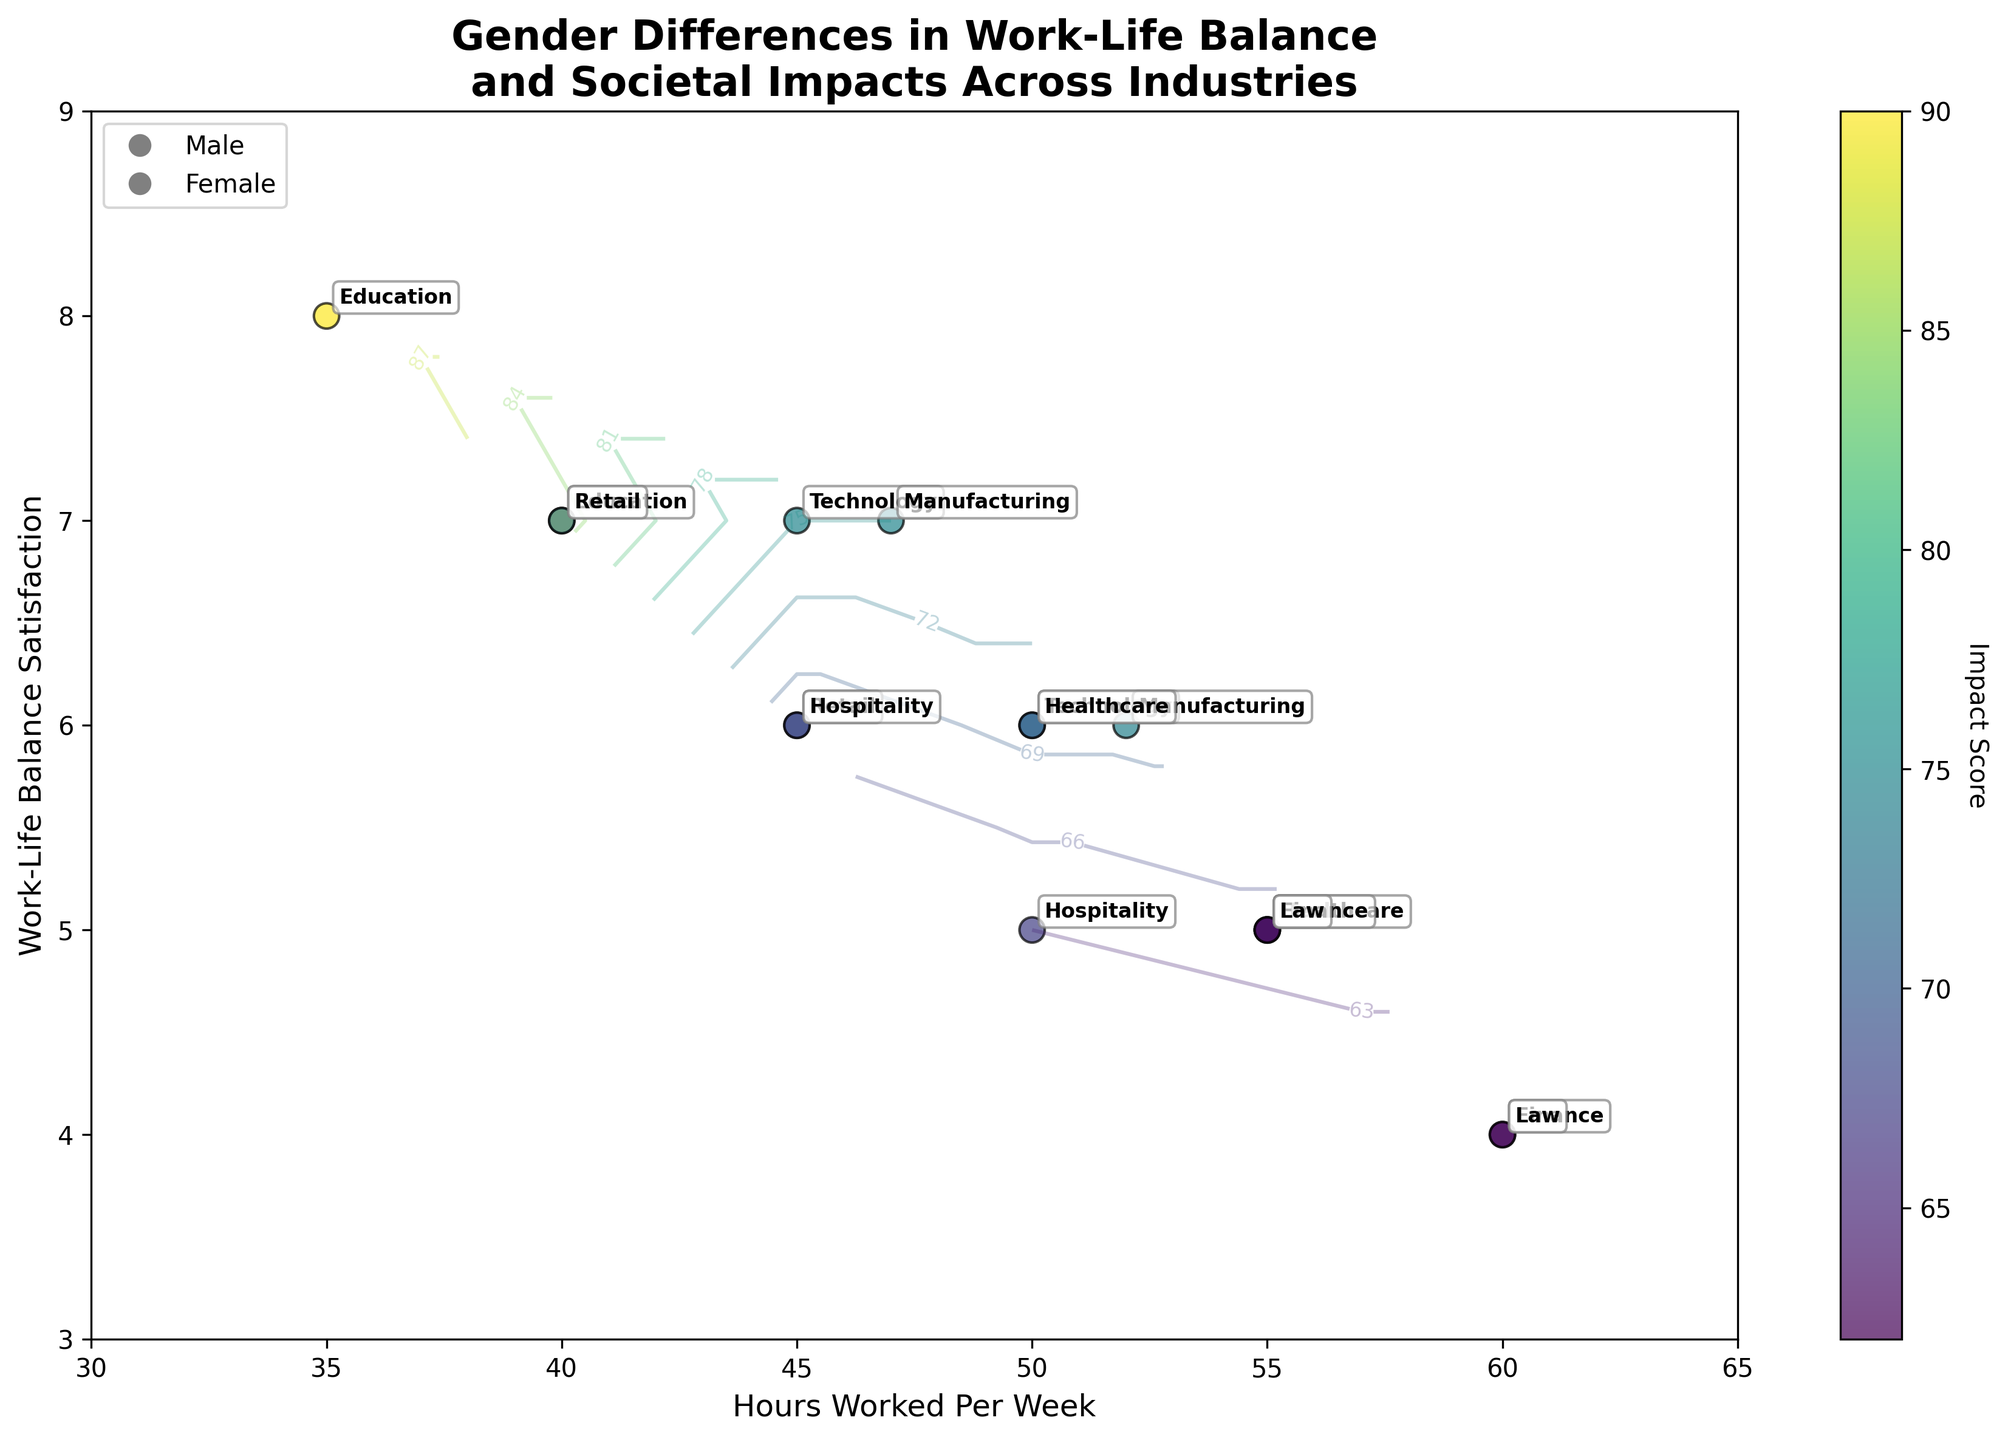What's the title of the figure? The title is at the top of the figure. It reads: "Gender Differences in Work-Life Balance and Societal Impacts Across Industries".
Answer: Gender Differences in Work-Life Balance and Societal Impacts Across Industries What does the color bar represent? The color bar is next to the plot, and its label indicates that it represents the "Impact Score".
Answer: Impact Score How many industries are annotated in the plot for male participants? We count the number of unique industry labels next to the male data points. There are 7 industries in total for male participants: Technology, Healthcare, Education, Finance, Manufacturing, Retail, Hospitality, and Law.
Answer: 7 What is the range of Work-Life Balance Satisfaction values displayed in the plot? We look at the y-axis and observe that it ranges from 3 to 9. The plot also confirms that all data points fall within this range.
Answer: 3 to 9 Which industry has the highest Work-Life Balance Satisfaction for females? We find the highest y-axis value for the female data points, which is in the Education industry, annotated at a satisfaction level of 8.
Answer: Education On average, do males or females work more hours per week? We compare the hours worked per week for males and females across all industries. Males consistently work more hours, with higher hours represented in the x-axis values.
Answer: Males Which gender shows a higher Work-Life Balance Satisfaction in the Healthcare industry? We find the y-axis values for the Healthcare industry, with females having a satisfaction level of 6, while males have a level of 5.
Answer: Females What is the range of Impact Scores presented in the contour plot? We refer to the color bar and observe the values it ranges from. The Impact Scores range from approximately 58 to 90.
Answer: 58 to 90 Is there any industry where both genders have the same Work-Life Balance Satisfaction? We look for instances where both genders' data points align on the y-axis value. In the Technology industry, males have a satisfaction level of 6, and females have 7. No industry shows the same value for both genders.
Answer: No In which industry do males have the highest Impact Score? We check the color intensity and contour lines for male data points. The Education industry shows the highest Impact Score for males, around 85.
Answer: Education 